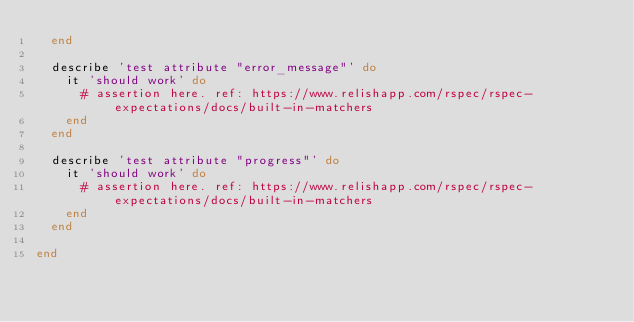Convert code to text. <code><loc_0><loc_0><loc_500><loc_500><_Ruby_>  end

  describe 'test attribute "error_message"' do
    it 'should work' do
      # assertion here. ref: https://www.relishapp.com/rspec/rspec-expectations/docs/built-in-matchers
    end
  end

  describe 'test attribute "progress"' do
    it 'should work' do
      # assertion here. ref: https://www.relishapp.com/rspec/rspec-expectations/docs/built-in-matchers
    end
  end

end
</code> 